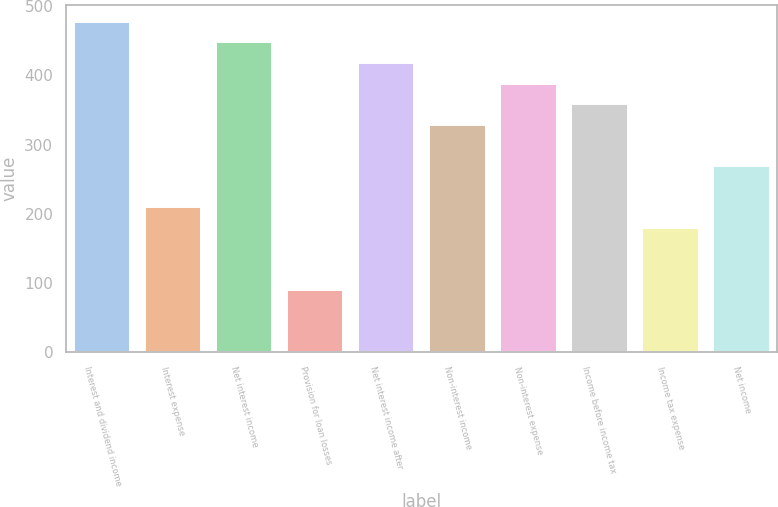<chart> <loc_0><loc_0><loc_500><loc_500><bar_chart><fcel>Interest and dividend income<fcel>Interest expense<fcel>Net interest income<fcel>Provision for loan losses<fcel>Net interest income after<fcel>Non-interest income<fcel>Non-interest expense<fcel>Income before income tax<fcel>Income tax expense<fcel>Net income<nl><fcel>477.45<fcel>208.98<fcel>447.62<fcel>89.66<fcel>417.79<fcel>328.3<fcel>387.96<fcel>358.13<fcel>179.15<fcel>268.64<nl></chart> 